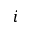Convert formula to latex. <formula><loc_0><loc_0><loc_500><loc_500>i</formula> 